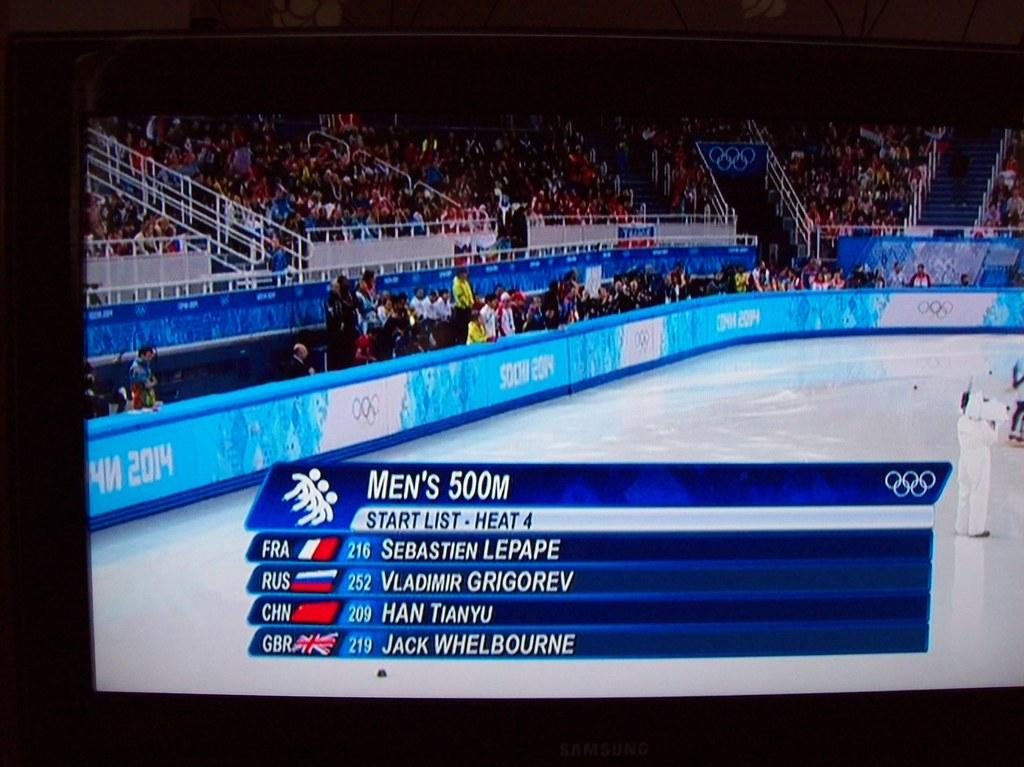Provide a one-sentence caption for the provided image. At a ice rink, the men's 500 meter start list is shown. 